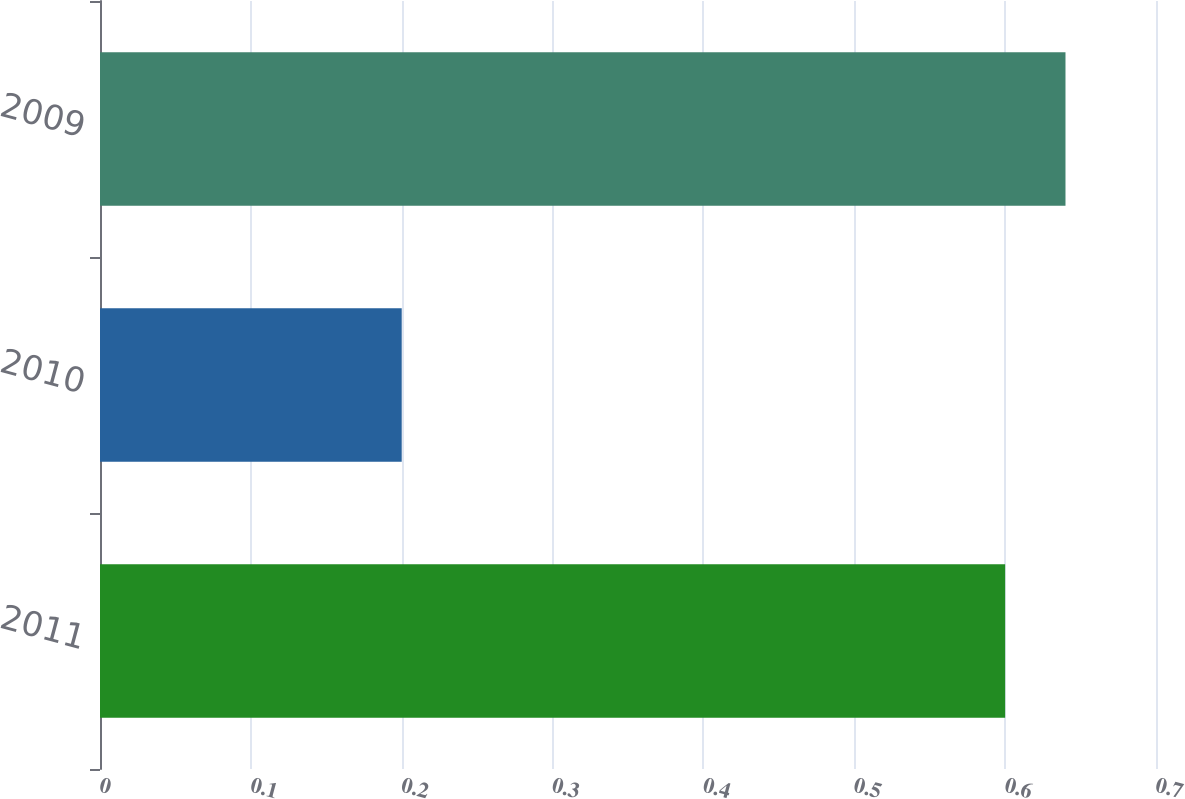<chart> <loc_0><loc_0><loc_500><loc_500><bar_chart><fcel>2011<fcel>2010<fcel>2009<nl><fcel>0.6<fcel>0.2<fcel>0.64<nl></chart> 